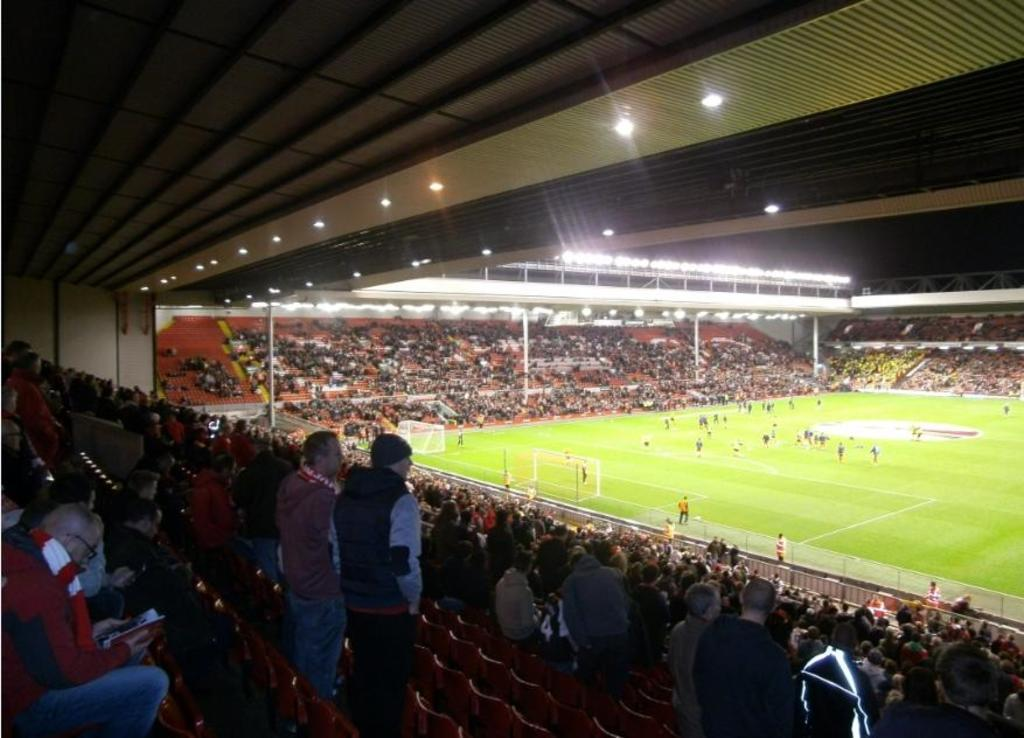How many people are in the image? There is a group of people in the image, but the exact number cannot be determined from the provided facts. What type of furniture is present in the image? There are chairs in the image. What are the people on the ground doing? There are people on the ground in the image, but their actions cannot be determined from the provided facts. What sports equipment is visible in the image? There is a football net in the image. What type of structure is present in the image? There are poles and a roof in the image, which suggests a covered area or a shelter. What type of illumination is present in the image? There are lights in the image. Can you describe any additional objects in the image? There are some objects in the image, but their nature cannot be determined from the provided facts. What type of animal is lying on the bed in the image? There is no bed or animal present in the image. What is the donkey doing in the image? There is no donkey present in the image. 